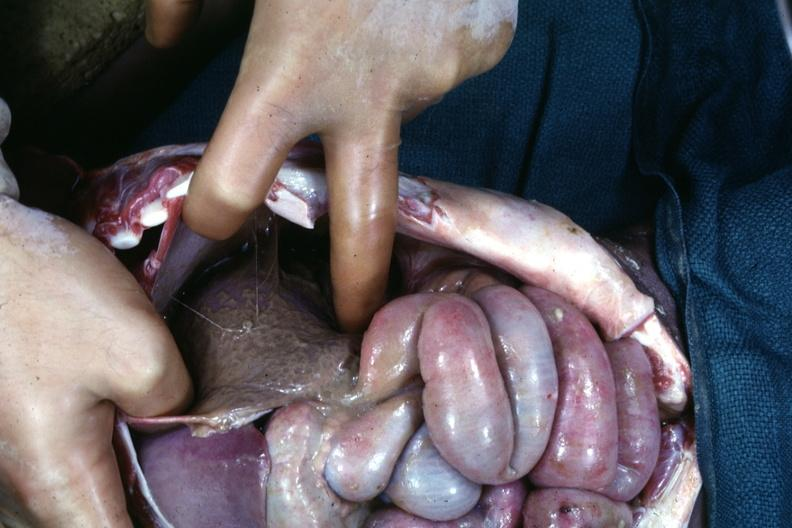s omentum present?
Answer the question using a single word or phrase. No 